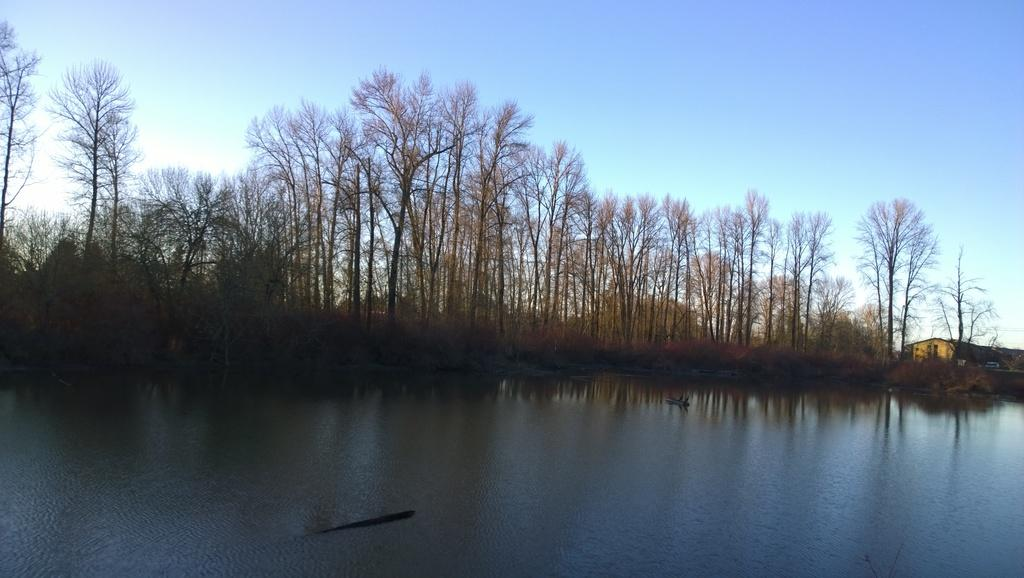What body of water is visible in the image? There is a lake in the image. What can be seen behind the lake? There are many trees behind the lake. How would you describe the sky in the image? The sky is clear in the image. What type of structure is present in the image? There is a building in the image. What thought process is the lake going through in the image? The lake is not capable of having thoughts, as it is a body of water. 